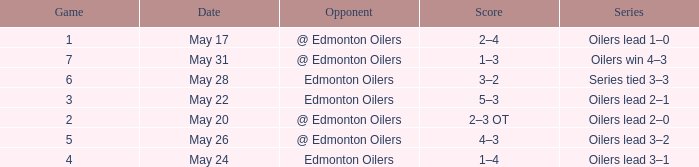Score of 2–3 ot on what date? May 20. 